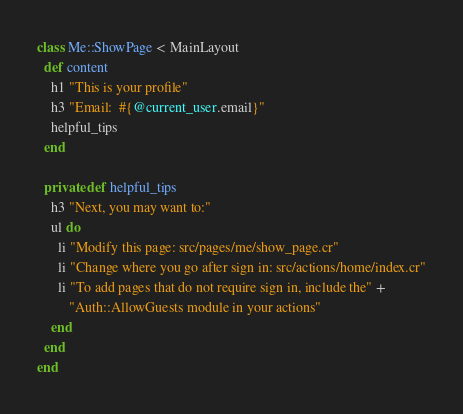<code> <loc_0><loc_0><loc_500><loc_500><_Crystal_>class Me::ShowPage < MainLayout
  def content
    h1 "This is your profile"
    h3 "Email:  #{@current_user.email}"
    helpful_tips
  end

  private def helpful_tips
    h3 "Next, you may want to:"
    ul do
      li "Modify this page: src/pages/me/show_page.cr"
      li "Change where you go after sign in: src/actions/home/index.cr"
      li "To add pages that do not require sign in, include the" +
         "Auth::AllowGuests module in your actions"
    end
  end
end
</code> 